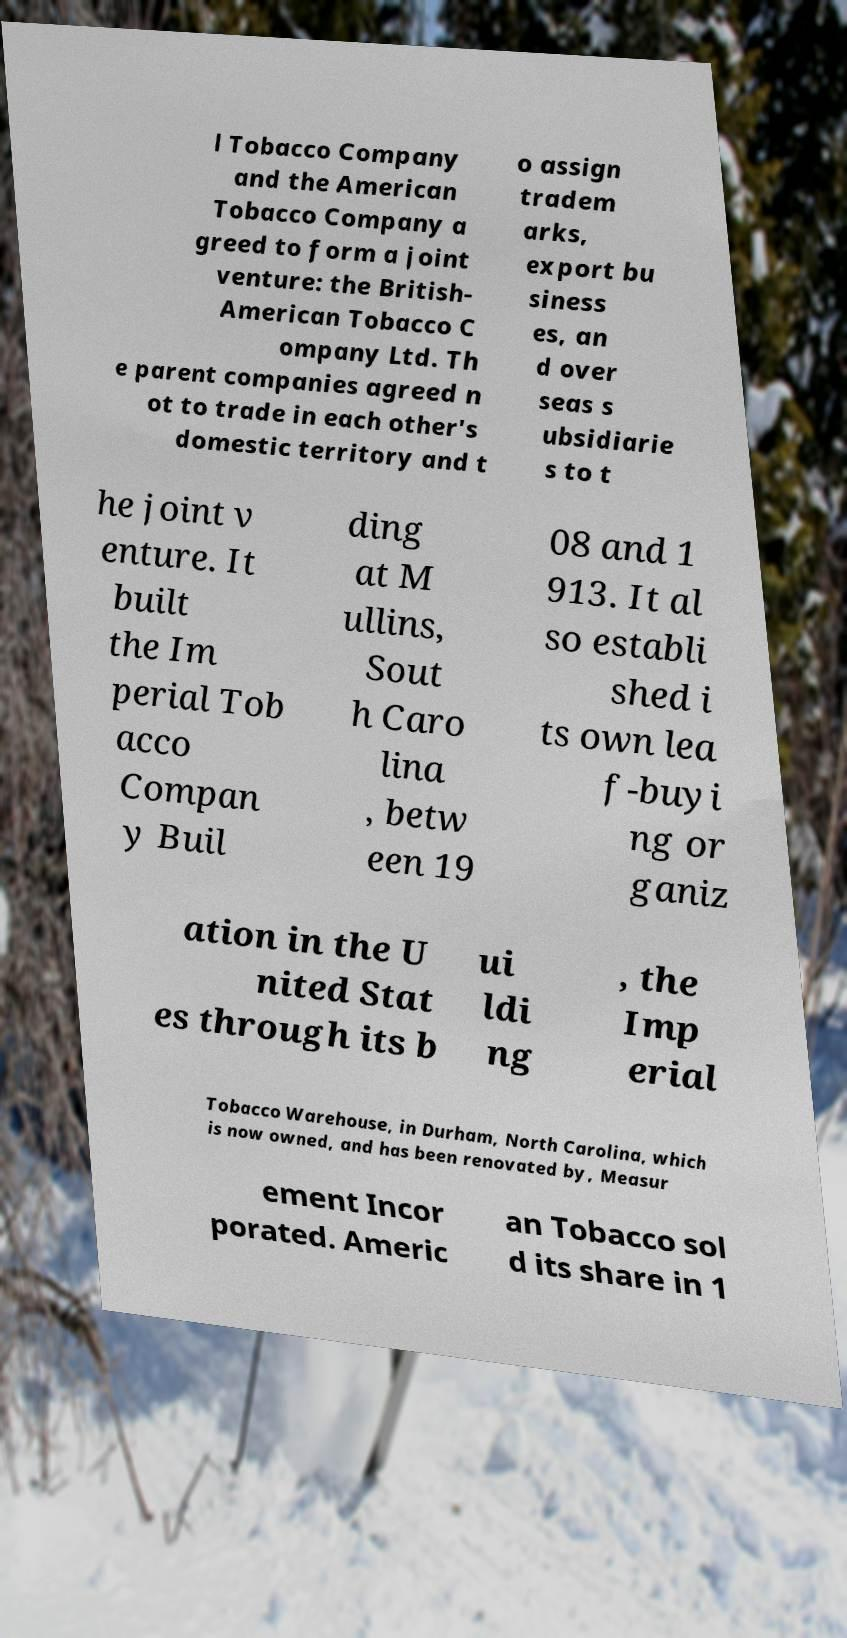I need the written content from this picture converted into text. Can you do that? l Tobacco Company and the American Tobacco Company a greed to form a joint venture: the British- American Tobacco C ompany Ltd. Th e parent companies agreed n ot to trade in each other's domestic territory and t o assign tradem arks, export bu siness es, an d over seas s ubsidiarie s to t he joint v enture. It built the Im perial Tob acco Compan y Buil ding at M ullins, Sout h Caro lina , betw een 19 08 and 1 913. It al so establi shed i ts own lea f-buyi ng or ganiz ation in the U nited Stat es through its b ui ldi ng , the Imp erial Tobacco Warehouse, in Durham, North Carolina, which is now owned, and has been renovated by, Measur ement Incor porated. Americ an Tobacco sol d its share in 1 